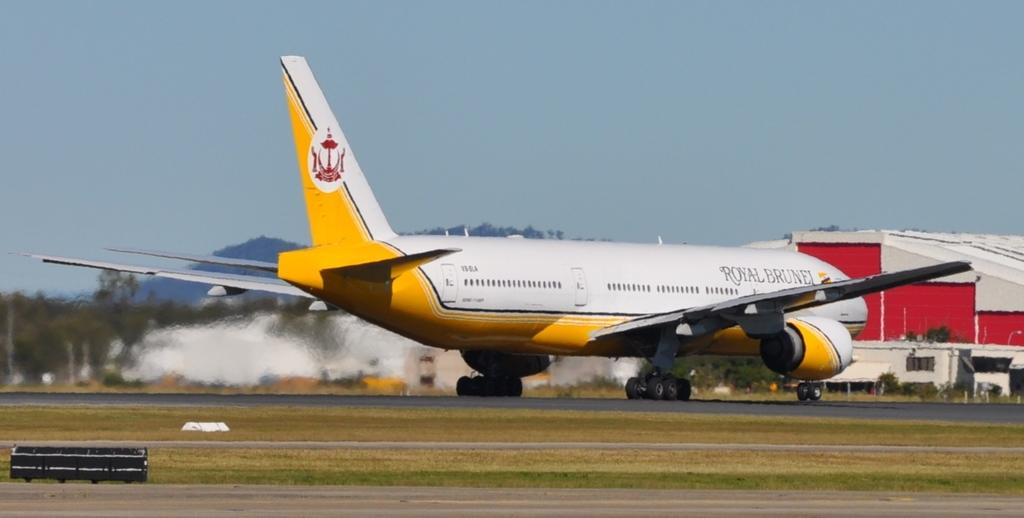<image>
Present a compact description of the photo's key features. A Royal Burnel airplane is sitting on the landing area. 